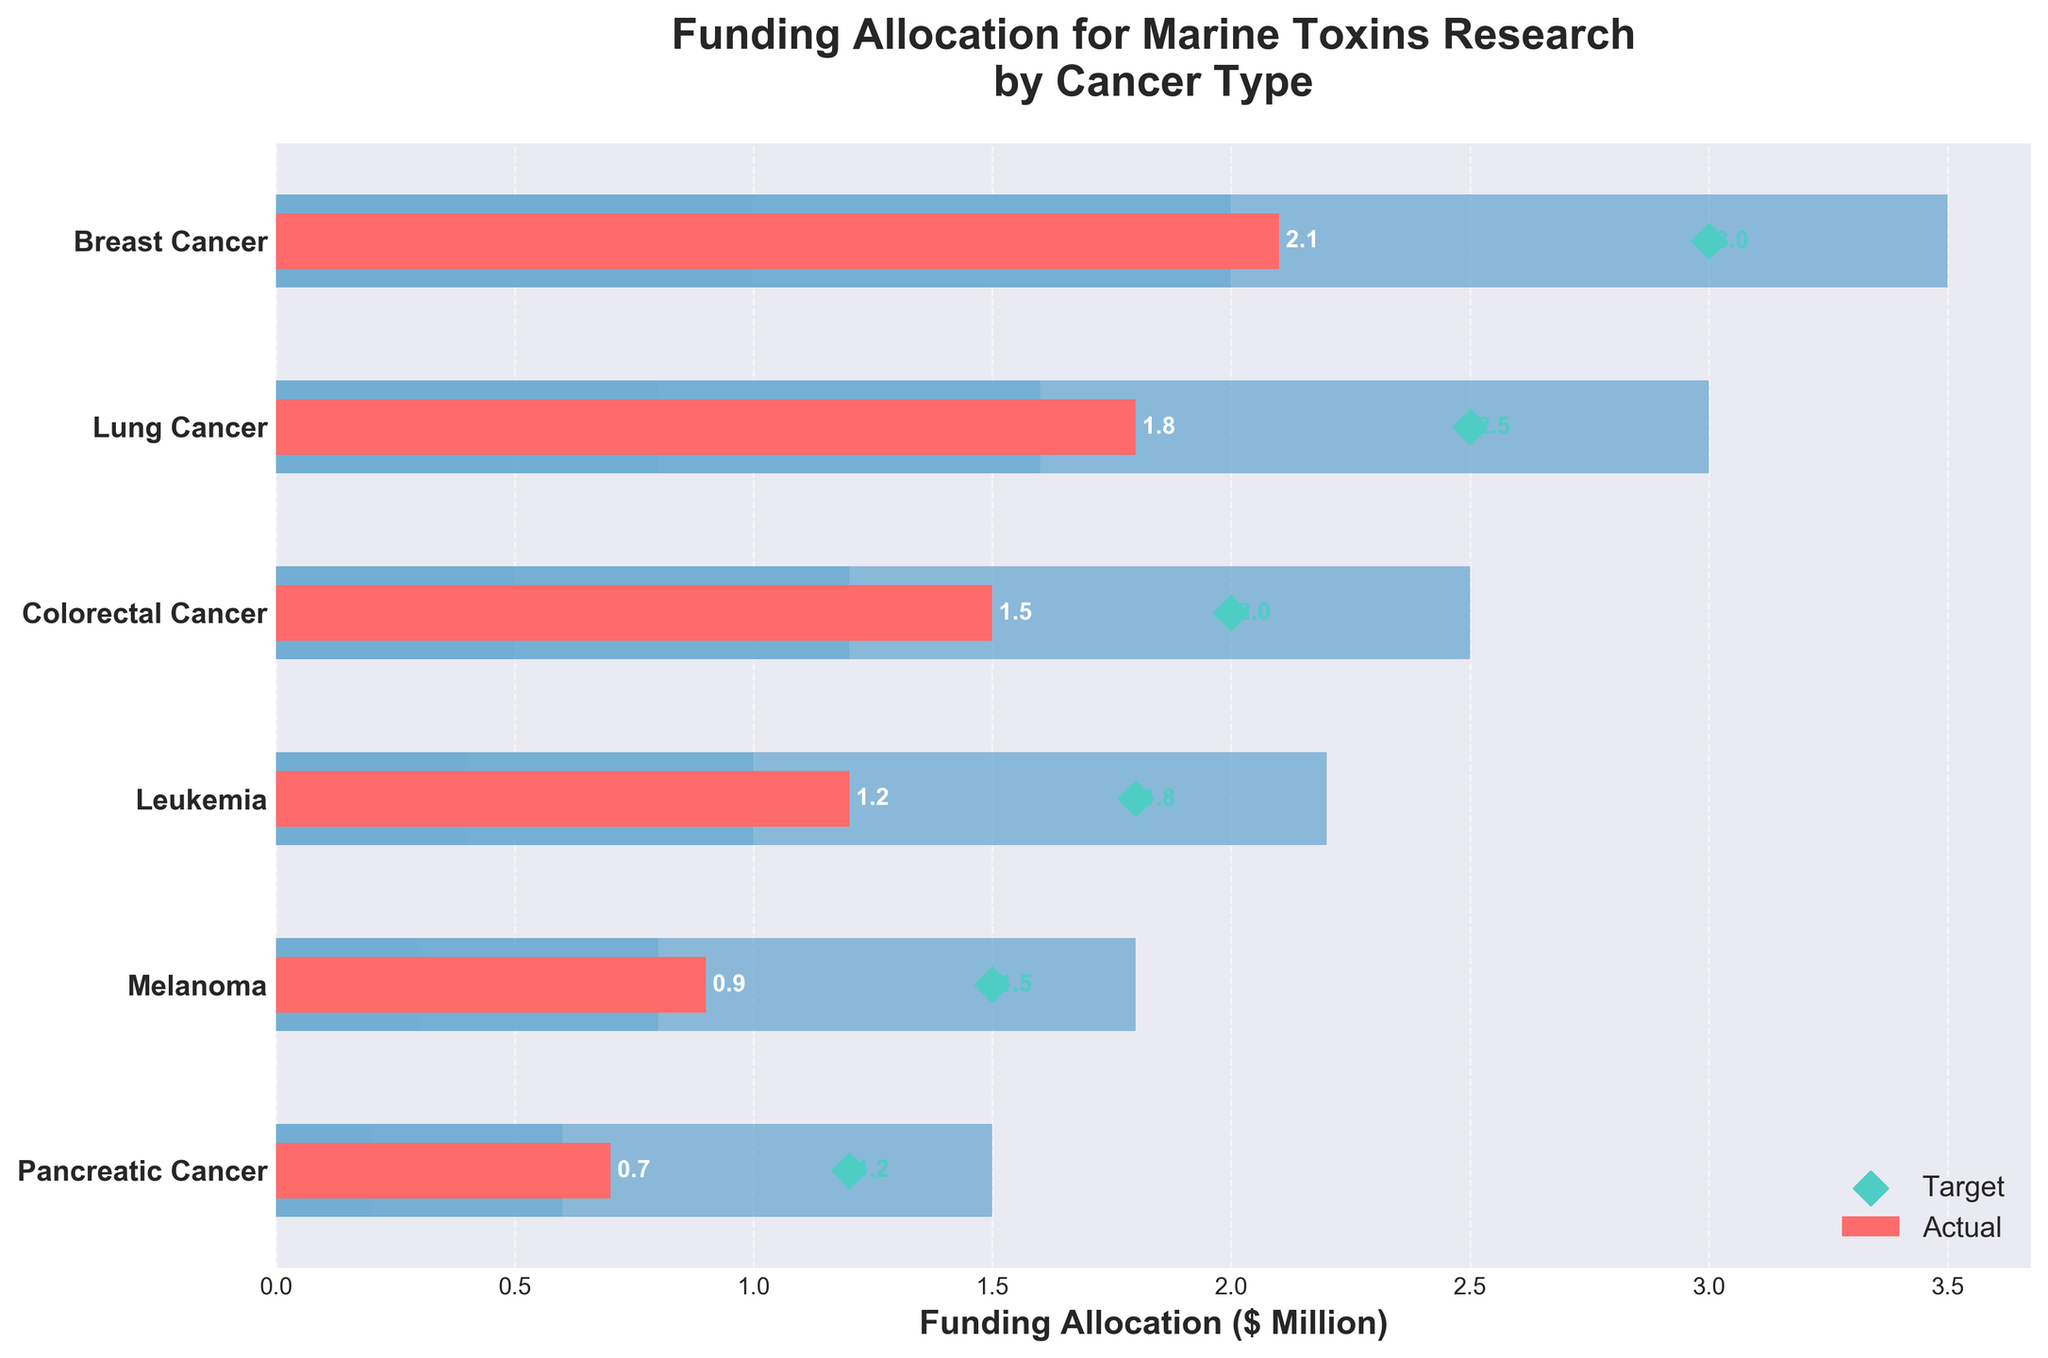What's the title of the figure? The title of a figure is usually displayed at the top and provides a summary of what the figure represents. In this case, it can be found directly at the top center of the chart.
Answer: Funding Allocation for Marine Toxins Research by Cancer Type What is the target funding allocation for Breast Cancer? To find the target funding allocation for Breast Cancer, look for the target marker, which is a diamond-shaped marker in the chart, corresponding to Breast Cancer.
Answer: 3.0 Which cancer type received the highest actual funding? To determine which cancer type received the highest actual funding, compare the lengths of the red bars that represent actual funding. The longest red bar indicates the highest actual funding.
Answer: Breast Cancer How much more funding is needed for Melanoma to reach its target? First, find the actual funding for Melanoma (0.9) and the target funding for Melanoma (1.5). Subtract the actual funding from the target funding (1.5 - 0.9).
Answer: 0.6 What is the difference between the actual and target funding allocation for Lung Cancer? Locate the actual funding for Lung Cancer (1.8) and the target funding (2.5). Subtract the actual funding from the target funding (2.5 - 1.8).
Answer: 0.7 How many cancer types have actual funding below 1.0 million? Identify the actual funding values less than 1.0 million and count the number of occurrences.
Answer: 3 Which cancer type is closest to reaching its target funding? Compare the differences between actual and target funding for each cancer type; the smallest difference indicates the cancer type closest to its target. Pancreatic Cancer has an actual funding of 0.7 and target of 1.2, with the smallest difference of 0.5 compared to others.
Answer: Pancreatic Cancer In which range does Leukemia’s actual funding fall? Determine Leukemia's actual funding (1.2) and compare it to the ranges provided (0.4-1.0 for Range1, 1.0-2.2 for Range2). Leukemia's actual funding falls in Range2.
Answer: Range2 What is the total target funding allocation across all cancer types? Sum the target funding values for all cancer types: 3.0 (Breast Cancer) + 2.5 (Lung Cancer) + 2.0 (Colorectal Cancer) + 1.8 (Leukemia) + 1.5 (Melanoma) + 1.2 (Pancreatic Cancer) = 12.0 million.
Answer: 12.0 Which range is the widest for Pancreatic Cancer? Compare the lengths of the ranges for Pancreatic Cancer: Range1 (0.2), Range2 (0.4), Range3 (0.9). The widest range has the greatest value.
Answer: Range3 